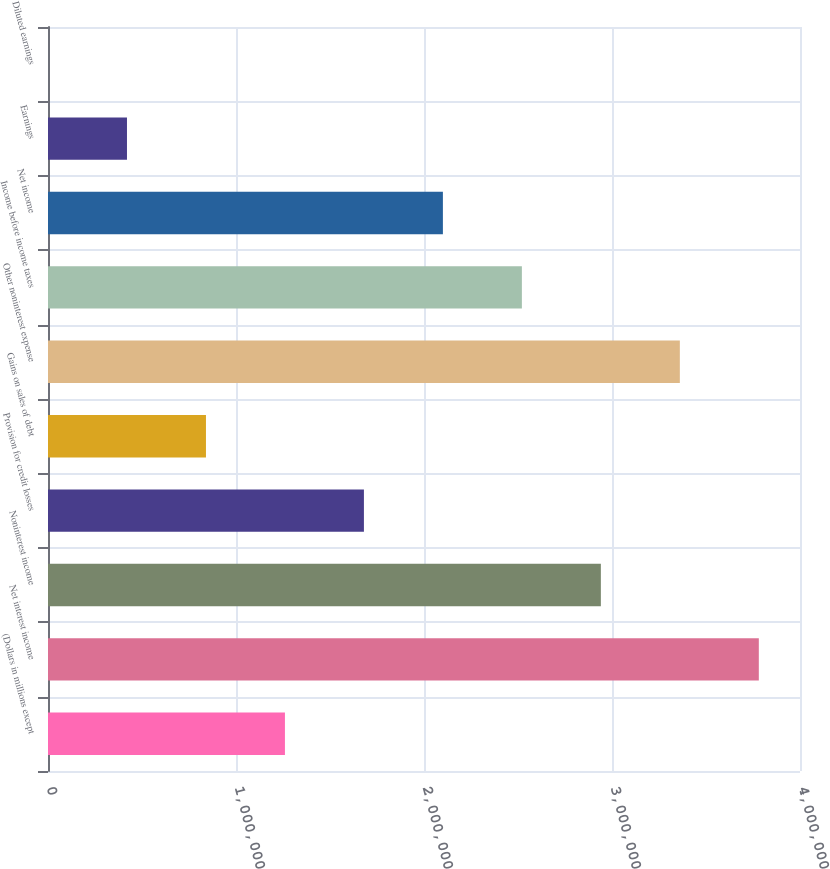Convert chart to OTSL. <chart><loc_0><loc_0><loc_500><loc_500><bar_chart><fcel>(Dollars in millions except<fcel>Net interest income<fcel>Noninterest income<fcel>Provision for credit losses<fcel>Gains on sales of debt<fcel>Other noninterest expense<fcel>Income before income taxes<fcel>Net income<fcel>Earnings<fcel>Diluted earnings<nl><fcel>1.26032e+06<fcel>3.78095e+06<fcel>2.94074e+06<fcel>1.68042e+06<fcel>840213<fcel>3.36084e+06<fcel>2.52063e+06<fcel>2.10053e+06<fcel>420108<fcel>3.17<nl></chart> 